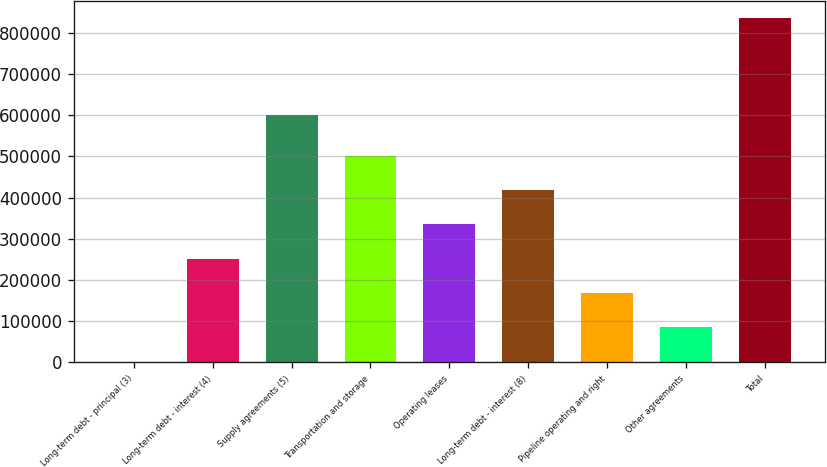Convert chart to OTSL. <chart><loc_0><loc_0><loc_500><loc_500><bar_chart><fcel>Long-term debt - principal (3)<fcel>Long-term debt - interest (4)<fcel>Supply agreements (5)<fcel>Transportation and storage<fcel>Operating leases<fcel>Long-term debt - interest (8)<fcel>Pipeline operating and right<fcel>Other agreements<fcel>Total<nl><fcel>1666<fcel>251842<fcel>599759<fcel>502019<fcel>335234<fcel>418626<fcel>168450<fcel>85058.1<fcel>835587<nl></chart> 